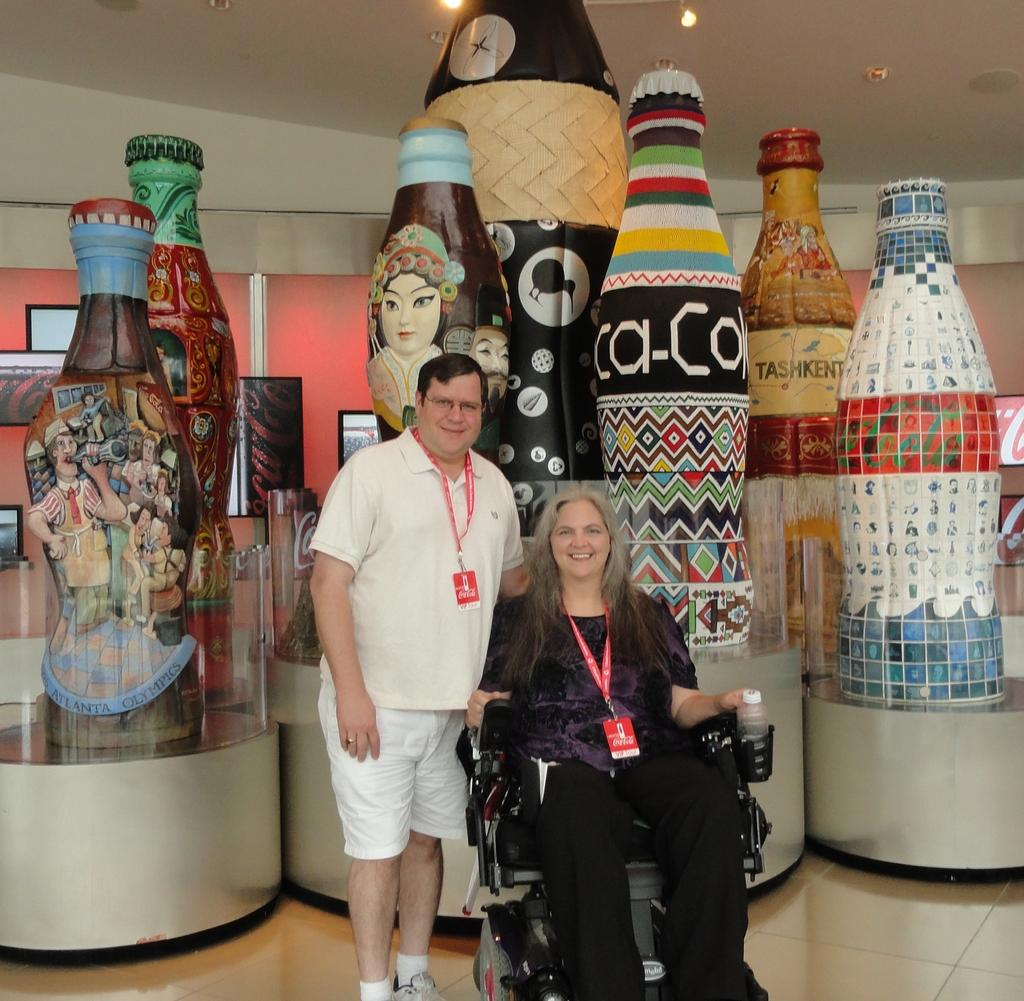How many individuals are present in the image? There are two people in the image. Can you describe the objects behind the people? There are bottles visible behind the people. What type of apparel is the rice wearing in the image? There is no rice present in the image, and therefore no apparel can be associated with it. 